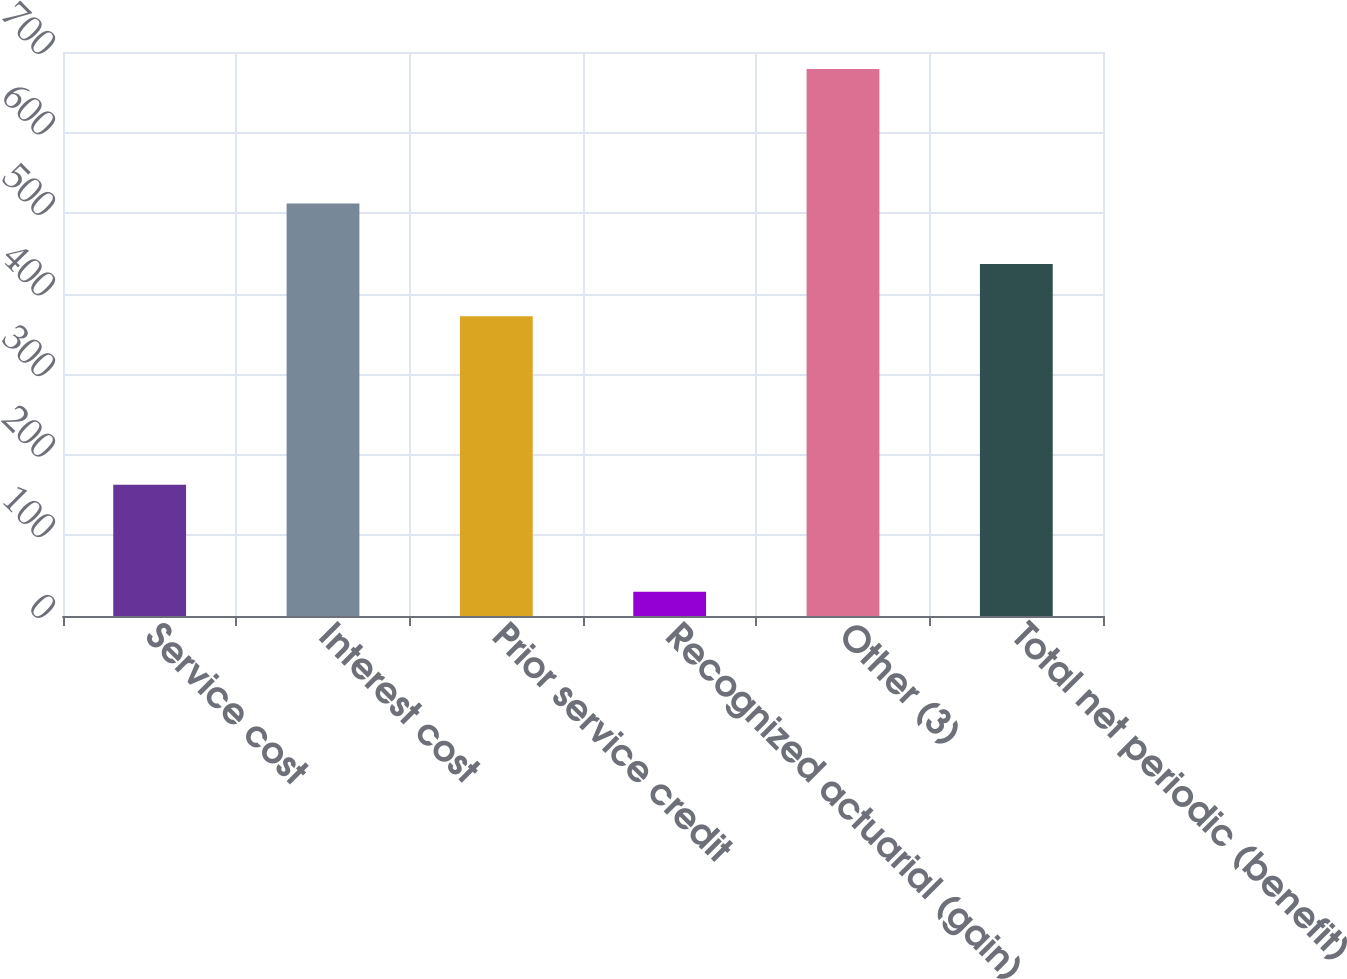<chart> <loc_0><loc_0><loc_500><loc_500><bar_chart><fcel>Service cost<fcel>Interest cost<fcel>Prior service credit<fcel>Recognized actuarial (gain)<fcel>Other (3)<fcel>Total net periodic (benefit)<nl><fcel>163<fcel>512<fcel>372<fcel>30<fcel>679<fcel>436.9<nl></chart> 